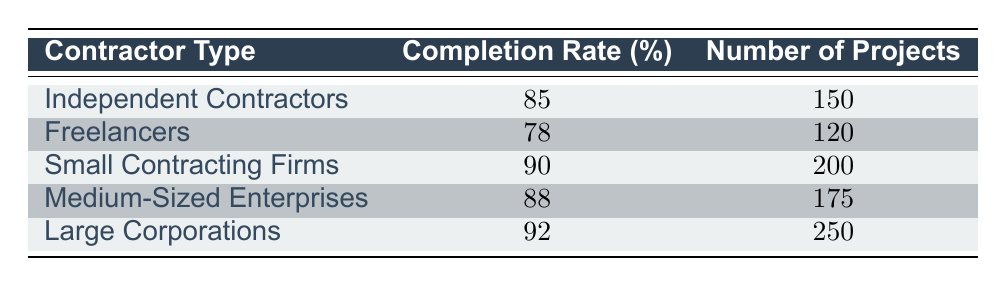What is the completion rate for Independent Contractors? The table shows that the completion rate for Independent Contractors is listed under the "Completion Rate (%)" column next to their type, which indicates that it is 85%.
Answer: 85% How many projects were completed by Large Corporations? The table shows that the number of projects for Large Corporations is listed under the "Number of Projects" column, which indicates that they completed 250 projects.
Answer: 250 Which contractor type has the highest completion rate? By reviewing the completion rates for each contractor type, it can be observed that Large Corporations have the highest completion rate at 92%.
Answer: Large Corporations What is the average completion rate of all contractor types? To find the average completion rate, add all the completion rates together: (85 + 78 + 90 + 88 + 92) = 433. Then divide by the number of contractor types, which is 5. Therefore, the average completion rate = 433 / 5 = 86.6%.
Answer: 86.6% Are Small Contracting Firms more successful in project completion compared to Freelancers? Small Contracting Firms have a completion rate of 90%, whereas Freelancers have a completion rate of 78%. Since 90% is greater than 78%, it is true that Small Contracting Firms are more successful in terms of project completion.
Answer: Yes How many projects were completed by Medium-Sized Enterprises and Freelancers combined? The number of projects for Medium-Sized Enterprises is 175 and for Freelancers it is 120. Adding these two numbers together gives 175 + 120 = 295.
Answer: 295 Is the completion rate for Medium-Sized Enterprises lower than that of Independent Contractors? The completion rate for Medium-Sized Enterprises is 88%, while the completion rate for Independent Contractors is 85%. Since 88% is greater than 85%, it is false that the Medium-Sized Enterprises have a lower completion rate.
Answer: No Which contractor type has a completion rate that is more than 5% greater than the average completion rate? The average completion rate is 86.6%. Comparing each contractor type's completion rate, Large Corporations (92%) and Small Contracting Firms (90%) are both more than 5% greater than the average.
Answer: Large Corporations, Small Contracting Firms What is the difference in the number of projects between Small Contracting Firms and Independent Contractors? The number of projects for Small Contracting Firms is 200, and the number of projects for Independent Contractors is 150. The difference in the number of projects is 200 - 150 = 50.
Answer: 50 